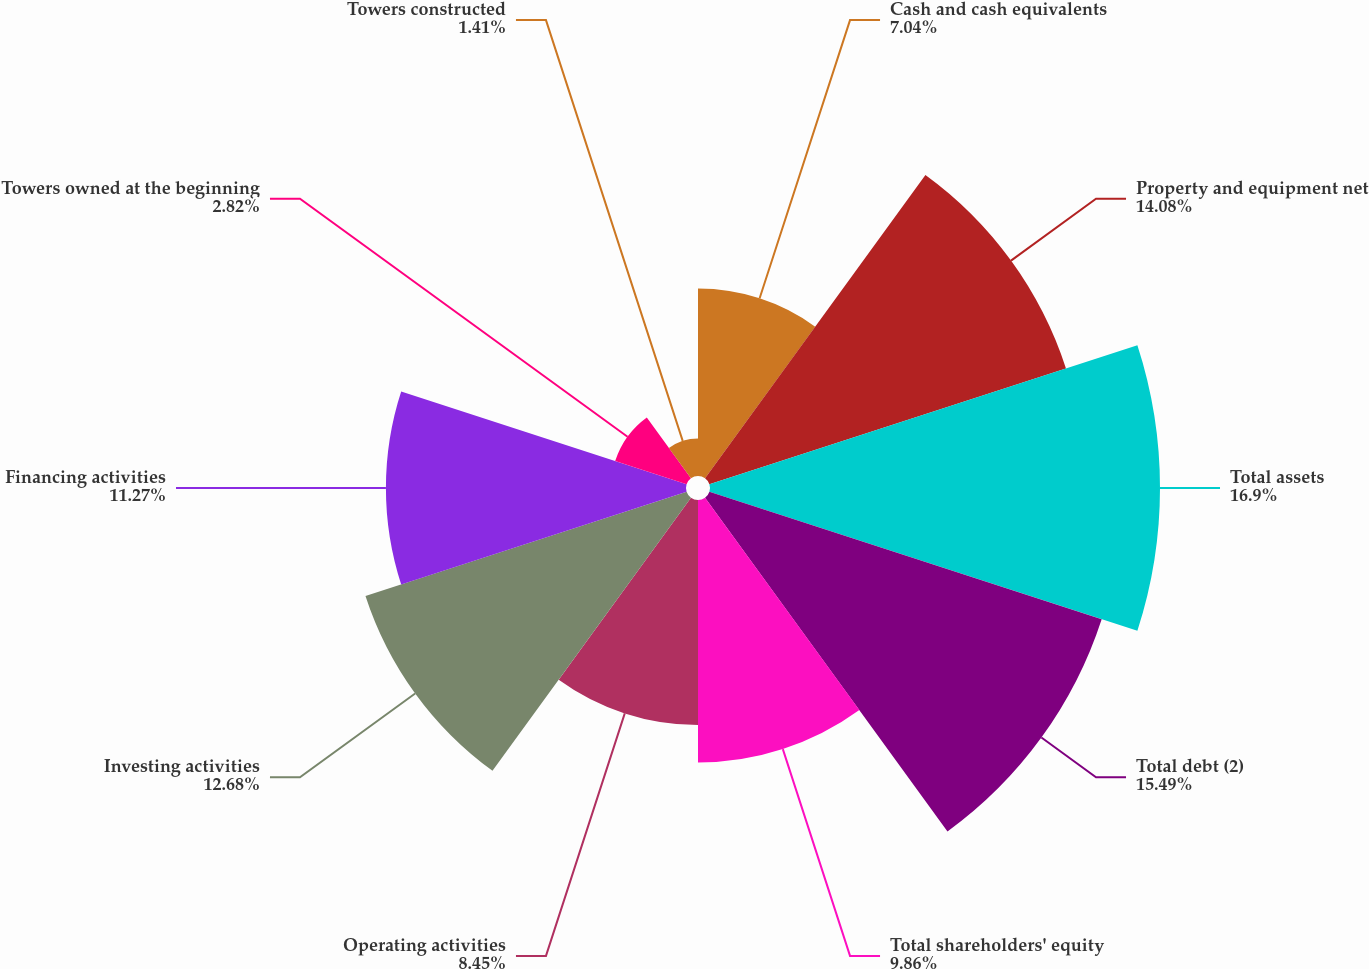Convert chart to OTSL. <chart><loc_0><loc_0><loc_500><loc_500><pie_chart><fcel>Cash and cash equivalents<fcel>Property and equipment net<fcel>Total assets<fcel>Total debt (2)<fcel>Total shareholders' equity<fcel>Operating activities<fcel>Investing activities<fcel>Financing activities<fcel>Towers owned at the beginning<fcel>Towers constructed<nl><fcel>7.04%<fcel>14.08%<fcel>16.9%<fcel>15.49%<fcel>9.86%<fcel>8.45%<fcel>12.68%<fcel>11.27%<fcel>2.82%<fcel>1.41%<nl></chart> 